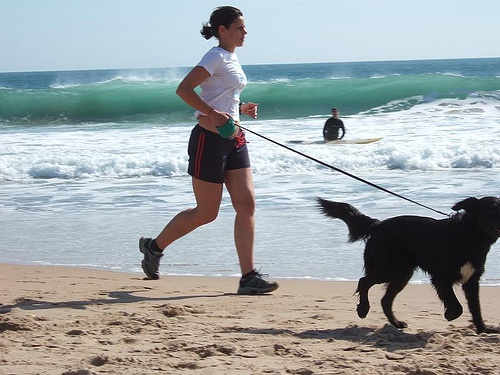Describe the objects in this image and their specific colors. I can see people in lightblue, black, maroon, gray, and brown tones, dog in lightblue, black, gray, darkgray, and tan tones, surfboard in lightblue, lightgray, darkgray, and gray tones, and people in lightblue, black, gray, and darkgray tones in this image. 